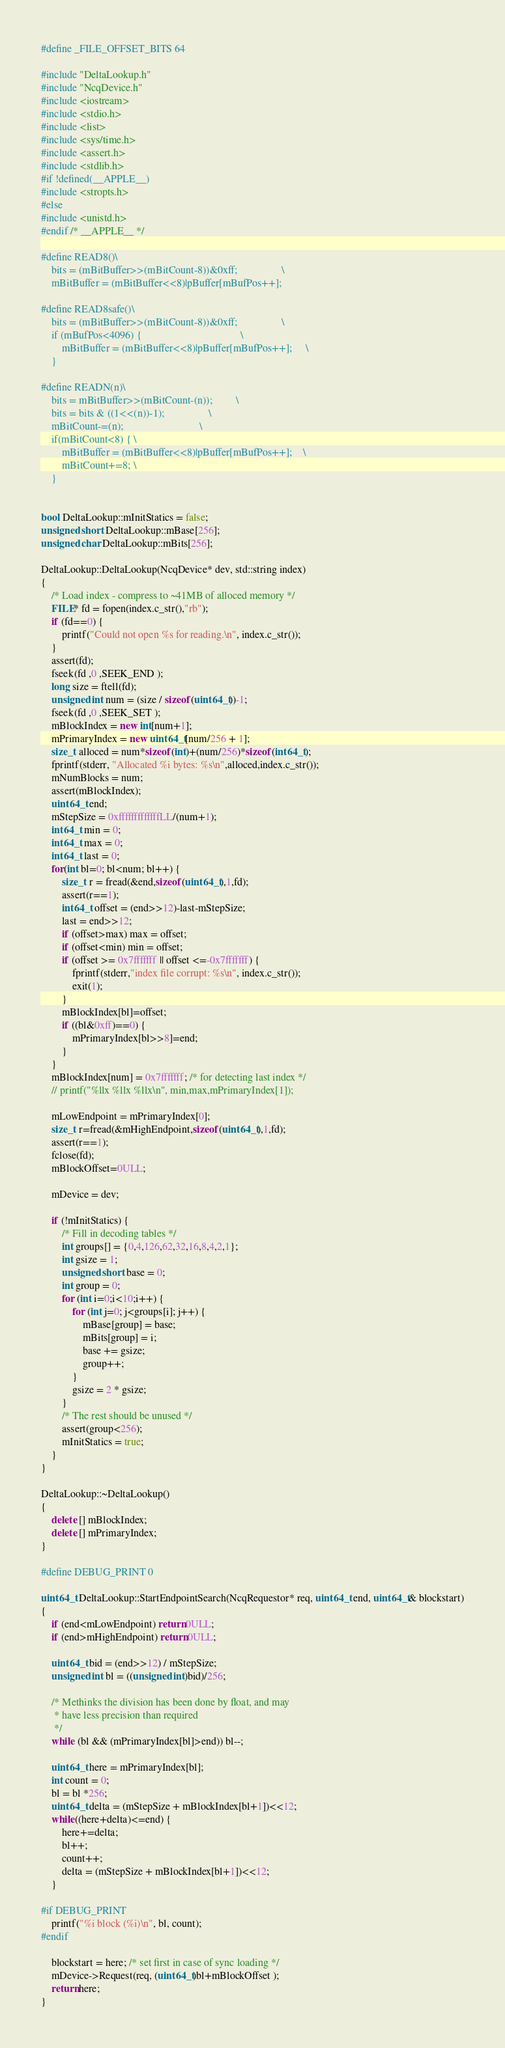<code> <loc_0><loc_0><loc_500><loc_500><_C++_>#define _FILE_OFFSET_BITS 64

#include "DeltaLookup.h"
#include "NcqDevice.h"
#include <iostream>
#include <stdio.h>
#include <list>
#include <sys/time.h>
#include <assert.h>
#include <stdlib.h>
#if !defined(__APPLE__)
#include <stropts.h>
#else 
#include <unistd.h>
#endif /* __APPLE__ */

#define READ8()\
    bits = (mBitBuffer>>(mBitCount-8))&0xff;                 \
    mBitBuffer = (mBitBuffer<<8)|pBuffer[mBufPos++];

#define READ8safe()\
    bits = (mBitBuffer>>(mBitCount-8))&0xff;                 \
    if (mBufPos<4096) {                                      \
        mBitBuffer = (mBitBuffer<<8)|pBuffer[mBufPos++];     \
    }

#define READN(n)\
    bits = mBitBuffer>>(mBitCount-(n));         \
    bits = bits & ((1<<(n))-1);                 \
    mBitCount-=(n);                             \
    if(mBitCount<8) { \
        mBitBuffer = (mBitBuffer<<8)|pBuffer[mBufPos++];    \
        mBitCount+=8; \
    } 


bool DeltaLookup::mInitStatics = false;
unsigned short DeltaLookup::mBase[256];
unsigned char DeltaLookup::mBits[256];

DeltaLookup::DeltaLookup(NcqDevice* dev, std::string index)
{
    /* Load index - compress to ~41MB of alloced memory */
    FILE* fd = fopen(index.c_str(),"rb");
    if (fd==0) {
        printf("Could not open %s for reading.\n", index.c_str());
    }
    assert(fd);
    fseek(fd ,0 ,SEEK_END );
    long size = ftell(fd);
    unsigned int num = (size / sizeof(uint64_t))-1;
    fseek(fd ,0 ,SEEK_SET );
    mBlockIndex = new int[num+1];
    mPrimaryIndex = new uint64_t[num/256 + 1];
    size_t alloced = num*sizeof(int)+(num/256)*sizeof(int64_t);
    fprintf(stderr, "Allocated %i bytes: %s\n",alloced,index.c_str());
    mNumBlocks = num;
    assert(mBlockIndex);
    uint64_t end;
    mStepSize = 0xfffffffffffffLL/(num+1);
    int64_t min = 0;
    int64_t max = 0;
    int64_t last = 0;
    for(int bl=0; bl<num; bl++) {
        size_t r = fread(&end,sizeof(uint64_t),1,fd);
        assert(r==1);
        int64_t offset = (end>>12)-last-mStepSize;
        last = end>>12;
        if (offset>max) max = offset;
        if (offset<min) min = offset;
        if (offset >= 0x7fffffff || offset <=-0x7fffffff) {
            fprintf(stderr,"index file corrupt: %s\n", index.c_str());
            exit(1);
        }
        mBlockIndex[bl]=offset;
        if ((bl&0xff)==0) {
            mPrimaryIndex[bl>>8]=end;
        }
    }
    mBlockIndex[num] = 0x7fffffff; /* for detecting last index */
    // printf("%llx %llx %llx\n", min,max,mPrimaryIndex[1]);

    mLowEndpoint = mPrimaryIndex[0];
    size_t r=fread(&mHighEndpoint,sizeof(uint64_t),1,fd);
    assert(r==1);
    fclose(fd);
    mBlockOffset=0ULL;

    mDevice = dev;

    if (!mInitStatics) {
        /* Fill in decoding tables */
        int groups[] = {0,4,126,62,32,16,8,4,2,1};
        int gsize = 1;
        unsigned short base = 0;
        int group = 0;
        for (int i=0;i<10;i++) {
            for (int j=0; j<groups[i]; j++) {
                mBase[group] = base;
                mBits[group] = i;
                base += gsize;
                group++;
            }
            gsize = 2 * gsize;
        }
        /* The rest should be unused */
        assert(group<256);
        mInitStatics = true;
    }
}

DeltaLookup::~DeltaLookup()
{
    delete [] mBlockIndex;
    delete [] mPrimaryIndex;
}

#define DEBUG_PRINT 0

uint64_t DeltaLookup::StartEndpointSearch(NcqRequestor* req, uint64_t end, uint64_t& blockstart)
{
    if (end<mLowEndpoint) return 0ULL;
    if (end>mHighEndpoint) return 0ULL;

    uint64_t bid = (end>>12) / mStepSize;
    unsigned int bl = ((unsigned int)bid)/256;

    /* Methinks the division has been done by float, and may 
     * have less precision than required
     */
    while (bl && (mPrimaryIndex[bl]>end)) bl--;

    uint64_t here = mPrimaryIndex[bl];
    int count = 0;
    bl = bl *256;
    uint64_t delta = (mStepSize + mBlockIndex[bl+1])<<12;
    while((here+delta)<=end) {
        here+=delta;
        bl++;
        count++;
        delta = (mStepSize + mBlockIndex[bl+1])<<12;
    }

#if DEBUG_PRINT
    printf("%i block (%i)\n", bl, count);
#endif

    blockstart = here; /* set first in case of sync loading */
    mDevice->Request(req, (uint64_t)bl+mBlockOffset );
    return here;
}
</code> 